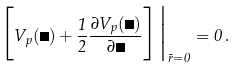Convert formula to latex. <formula><loc_0><loc_0><loc_500><loc_500>\Big [ V _ { p } ( \Phi ) + \frac { 1 } { 2 } \frac { \partial V _ { p } ( \Phi ) } { \partial \Phi } \Big ] \Big | _ { \vec { r } = 0 } = 0 \, .</formula> 